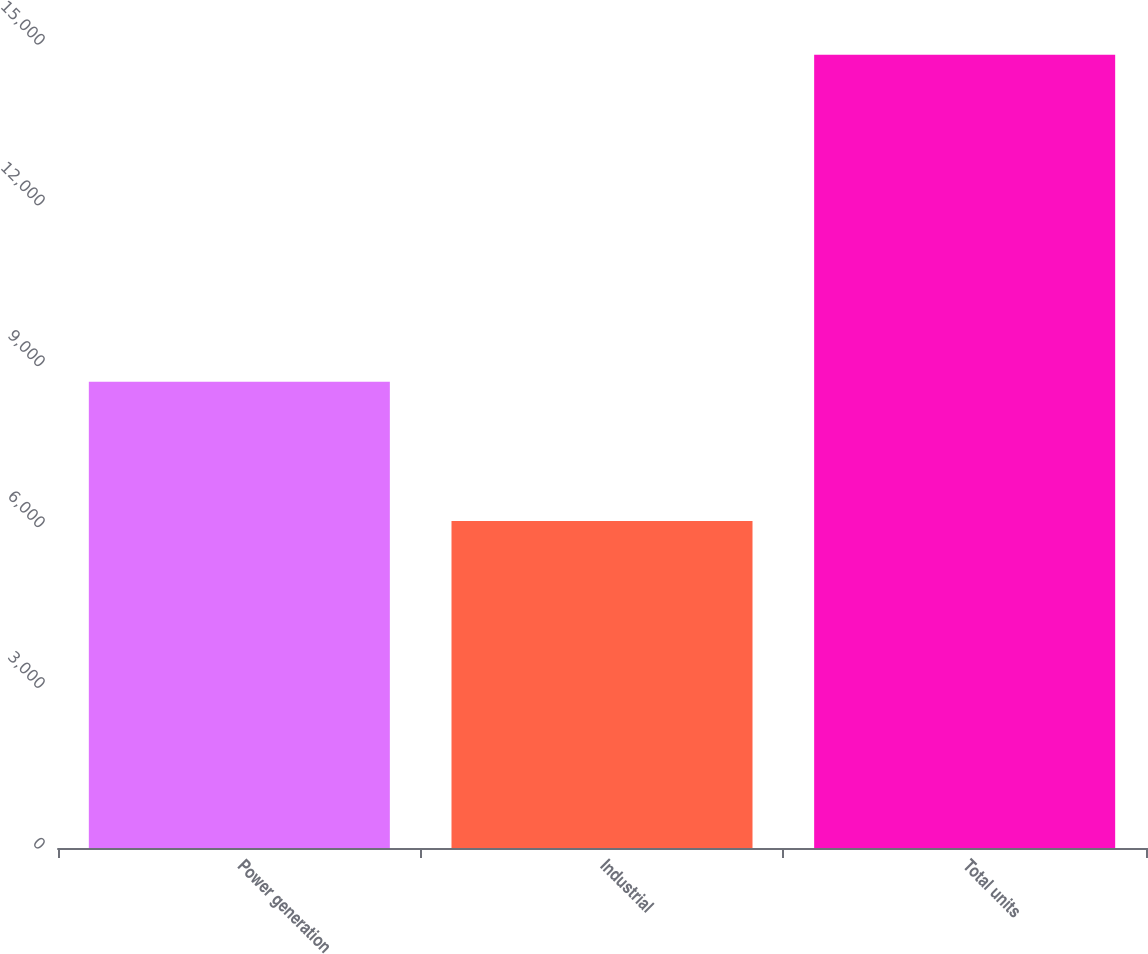<chart> <loc_0><loc_0><loc_500><loc_500><bar_chart><fcel>Power generation<fcel>Industrial<fcel>Total units<nl><fcel>8700<fcel>6100<fcel>14800<nl></chart> 